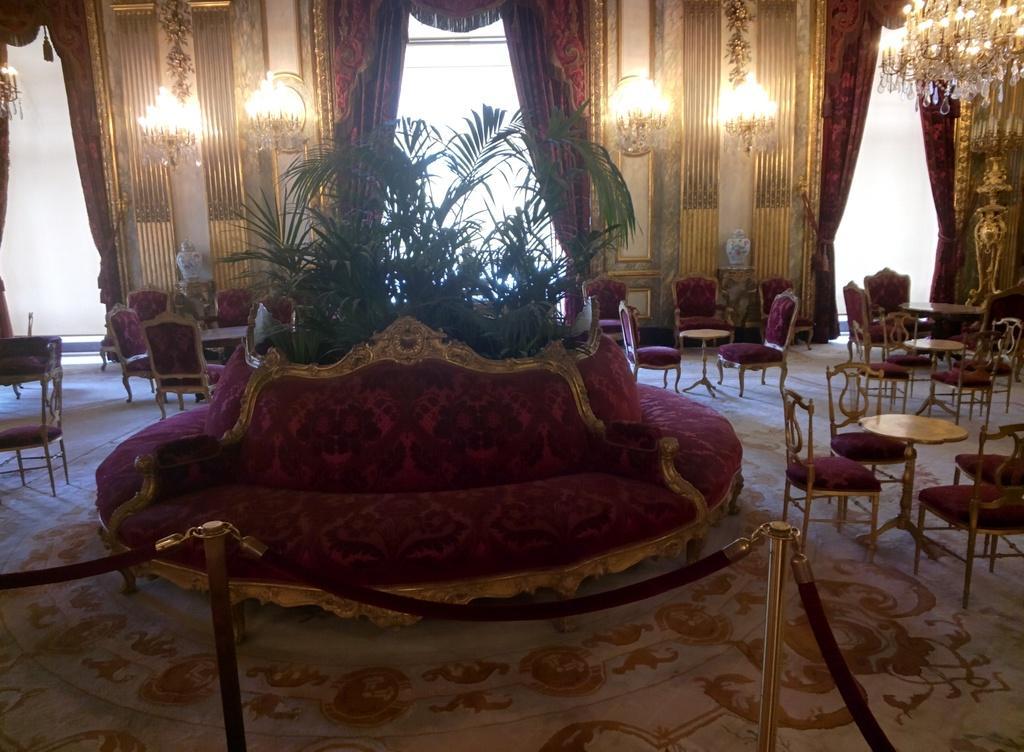Can you describe this image briefly? As we can see in the image there is a curtain, lights, plants and few chairs and tables. 